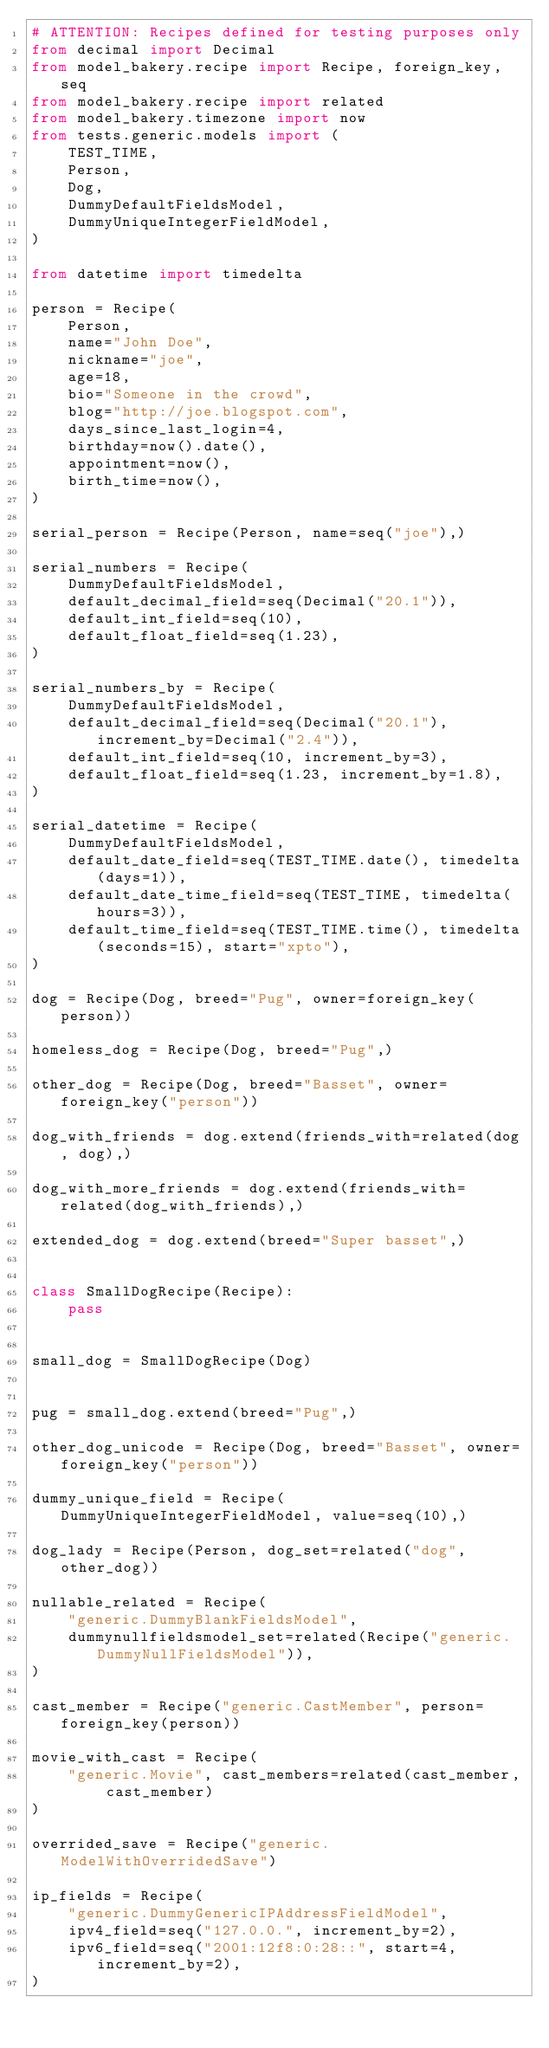<code> <loc_0><loc_0><loc_500><loc_500><_Python_># ATTENTION: Recipes defined for testing purposes only
from decimal import Decimal
from model_bakery.recipe import Recipe, foreign_key, seq
from model_bakery.recipe import related
from model_bakery.timezone import now
from tests.generic.models import (
    TEST_TIME,
    Person,
    Dog,
    DummyDefaultFieldsModel,
    DummyUniqueIntegerFieldModel,
)

from datetime import timedelta

person = Recipe(
    Person,
    name="John Doe",
    nickname="joe",
    age=18,
    bio="Someone in the crowd",
    blog="http://joe.blogspot.com",
    days_since_last_login=4,
    birthday=now().date(),
    appointment=now(),
    birth_time=now(),
)

serial_person = Recipe(Person, name=seq("joe"),)

serial_numbers = Recipe(
    DummyDefaultFieldsModel,
    default_decimal_field=seq(Decimal("20.1")),
    default_int_field=seq(10),
    default_float_field=seq(1.23),
)

serial_numbers_by = Recipe(
    DummyDefaultFieldsModel,
    default_decimal_field=seq(Decimal("20.1"), increment_by=Decimal("2.4")),
    default_int_field=seq(10, increment_by=3),
    default_float_field=seq(1.23, increment_by=1.8),
)

serial_datetime = Recipe(
    DummyDefaultFieldsModel,
    default_date_field=seq(TEST_TIME.date(), timedelta(days=1)),
    default_date_time_field=seq(TEST_TIME, timedelta(hours=3)),
    default_time_field=seq(TEST_TIME.time(), timedelta(seconds=15), start="xpto"),
)

dog = Recipe(Dog, breed="Pug", owner=foreign_key(person))

homeless_dog = Recipe(Dog, breed="Pug",)

other_dog = Recipe(Dog, breed="Basset", owner=foreign_key("person"))

dog_with_friends = dog.extend(friends_with=related(dog, dog),)

dog_with_more_friends = dog.extend(friends_with=related(dog_with_friends),)

extended_dog = dog.extend(breed="Super basset",)


class SmallDogRecipe(Recipe):
    pass


small_dog = SmallDogRecipe(Dog)


pug = small_dog.extend(breed="Pug",)

other_dog_unicode = Recipe(Dog, breed="Basset", owner=foreign_key("person"))

dummy_unique_field = Recipe(DummyUniqueIntegerFieldModel, value=seq(10),)

dog_lady = Recipe(Person, dog_set=related("dog", other_dog))

nullable_related = Recipe(
    "generic.DummyBlankFieldsModel",
    dummynullfieldsmodel_set=related(Recipe("generic.DummyNullFieldsModel")),
)

cast_member = Recipe("generic.CastMember", person=foreign_key(person))

movie_with_cast = Recipe(
    "generic.Movie", cast_members=related(cast_member, cast_member)
)

overrided_save = Recipe("generic.ModelWithOverridedSave")

ip_fields = Recipe(
    "generic.DummyGenericIPAddressFieldModel",
    ipv4_field=seq("127.0.0.", increment_by=2),
    ipv6_field=seq("2001:12f8:0:28::", start=4, increment_by=2),
)
</code> 